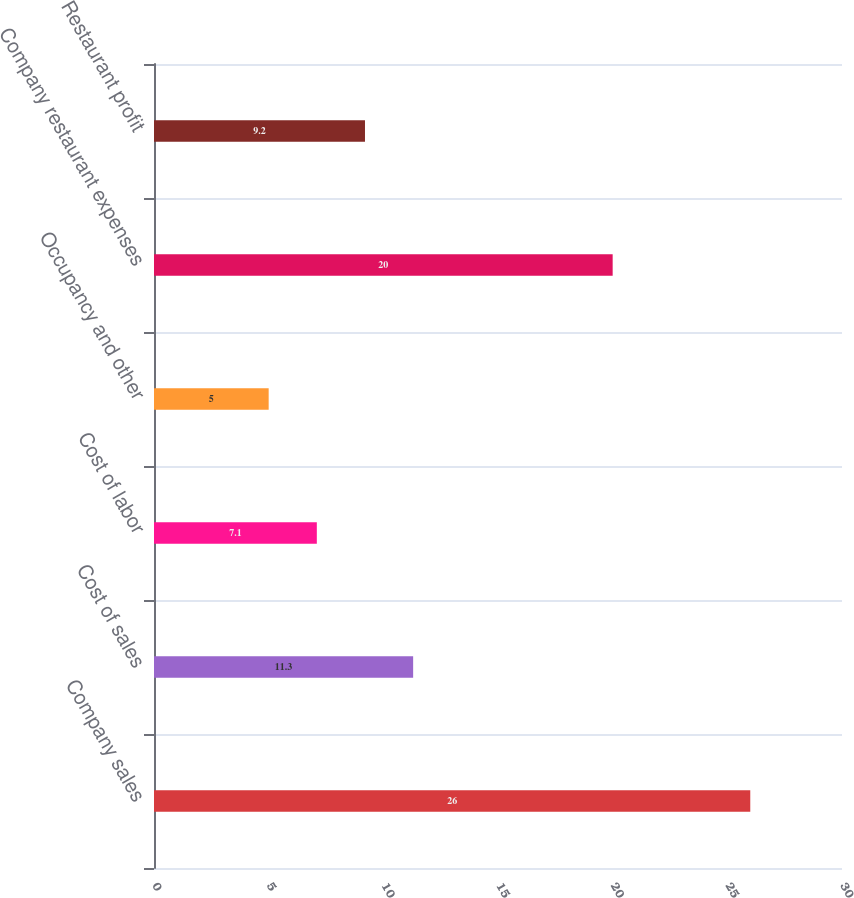Convert chart. <chart><loc_0><loc_0><loc_500><loc_500><bar_chart><fcel>Company sales<fcel>Cost of sales<fcel>Cost of labor<fcel>Occupancy and other<fcel>Company restaurant expenses<fcel>Restaurant profit<nl><fcel>26<fcel>11.3<fcel>7.1<fcel>5<fcel>20<fcel>9.2<nl></chart> 